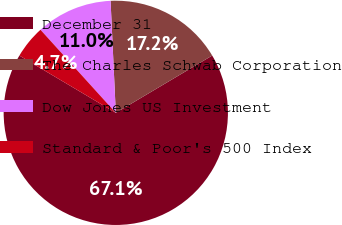Convert chart to OTSL. <chart><loc_0><loc_0><loc_500><loc_500><pie_chart><fcel>December 31<fcel>The Charles Schwab Corporation<fcel>Dow Jones US Investment<fcel>Standard & Poor's 500 Index<nl><fcel>67.07%<fcel>17.21%<fcel>10.98%<fcel>4.75%<nl></chart> 